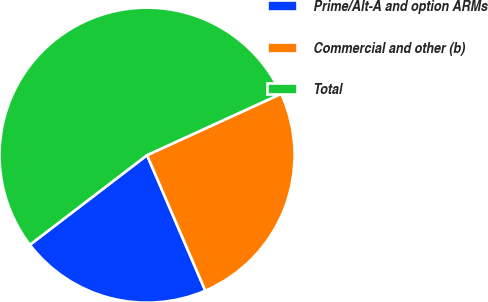<chart> <loc_0><loc_0><loc_500><loc_500><pie_chart><fcel>Prime/Alt-A and option ARMs<fcel>Commercial and other (b)<fcel>Total<nl><fcel>21.07%<fcel>25.37%<fcel>53.56%<nl></chart> 